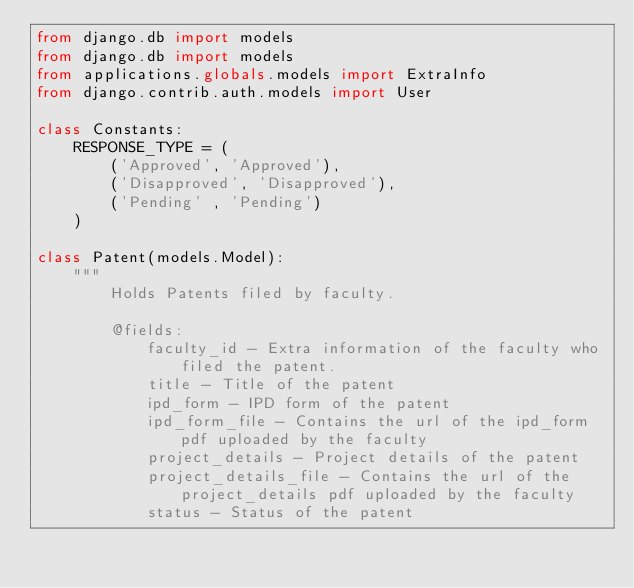<code> <loc_0><loc_0><loc_500><loc_500><_Python_>from django.db import models
from django.db import models
from applications.globals.models import ExtraInfo
from django.contrib.auth.models import User

class Constants:
    RESPONSE_TYPE = (
        ('Approved', 'Approved'),
        ('Disapproved', 'Disapproved'),
        ('Pending' , 'Pending')
    )

class Patent(models.Model):
    """
        Holds Patents filed by faculty.

        @fields:
            faculty_id - Extra information of the faculty who filed the patent.
            title - Title of the patent
            ipd_form - IPD form of the patent
            ipd_form_file - Contains the url of the ipd_form pdf uploaded by the faculty
            project_details - Project details of the patent
            project_details_file - Contains the url of the project_details pdf uploaded by the faculty
            status - Status of the patent</code> 